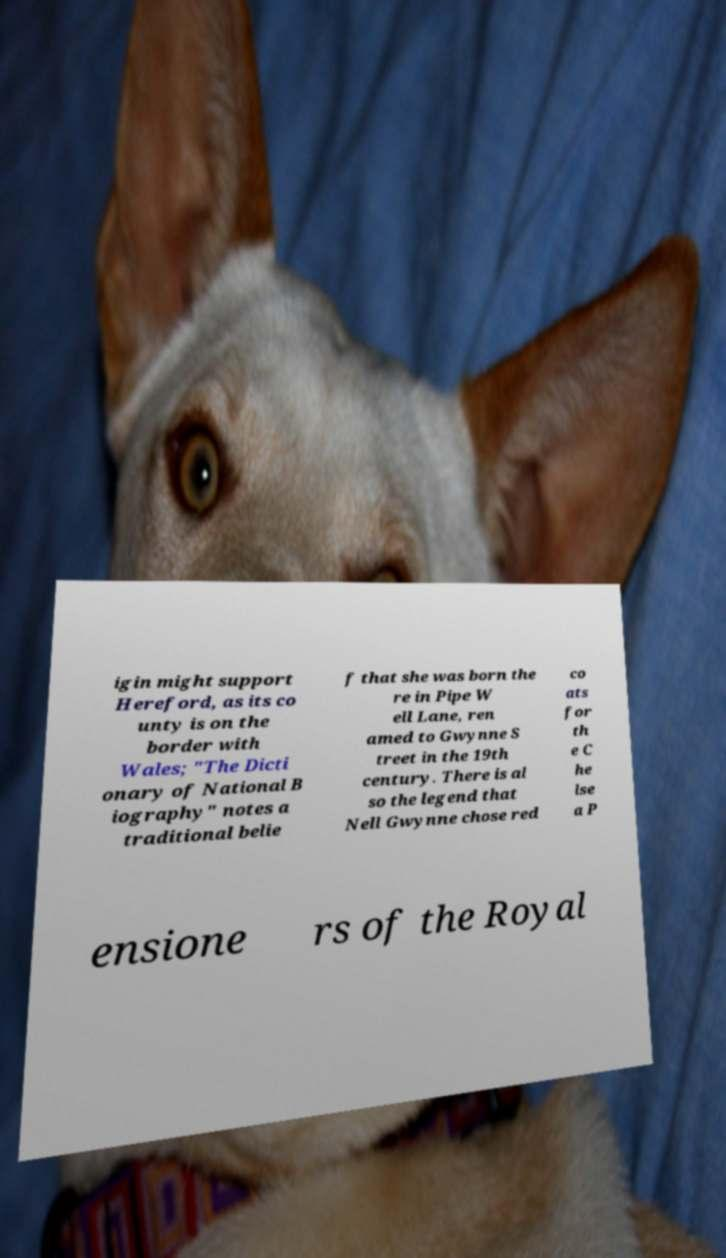Can you read and provide the text displayed in the image?This photo seems to have some interesting text. Can you extract and type it out for me? igin might support Hereford, as its co unty is on the border with Wales; "The Dicti onary of National B iography" notes a traditional belie f that she was born the re in Pipe W ell Lane, ren amed to Gwynne S treet in the 19th century. There is al so the legend that Nell Gwynne chose red co ats for th e C he lse a P ensione rs of the Royal 